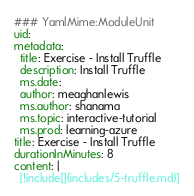<code> <loc_0><loc_0><loc_500><loc_500><_YAML_>### YamlMime:ModuleUnit
uid: 
metadata:
  title: Exercise - Install Truffle
  description: Install Truffle
  ms.date: 
  author: meaghanlewis
  ms.author: shanama
  ms.topic: interactive-tutorial
  ms.prod: learning-azure
title: Exercise - Install Truffle
durationInMinutes: 8
content: |
  [!include[](includes/5-truffle.md)]</code> 